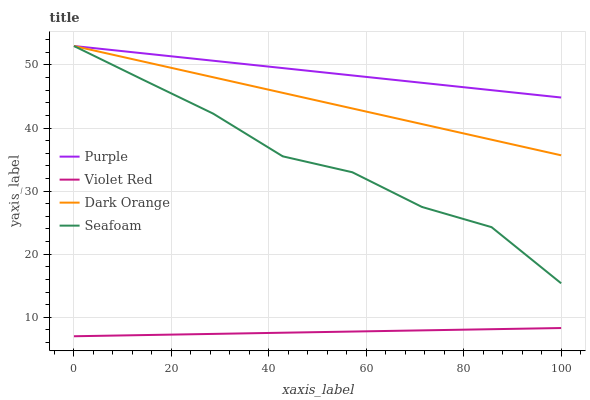Does Violet Red have the minimum area under the curve?
Answer yes or no. Yes. Does Purple have the maximum area under the curve?
Answer yes or no. Yes. Does Dark Orange have the minimum area under the curve?
Answer yes or no. No. Does Dark Orange have the maximum area under the curve?
Answer yes or no. No. Is Violet Red the smoothest?
Answer yes or no. Yes. Is Seafoam the roughest?
Answer yes or no. Yes. Is Dark Orange the smoothest?
Answer yes or no. No. Is Dark Orange the roughest?
Answer yes or no. No. Does Violet Red have the lowest value?
Answer yes or no. Yes. Does Dark Orange have the lowest value?
Answer yes or no. No. Does Seafoam have the highest value?
Answer yes or no. Yes. Does Violet Red have the highest value?
Answer yes or no. No. Is Violet Red less than Dark Orange?
Answer yes or no. Yes. Is Seafoam greater than Violet Red?
Answer yes or no. Yes. Does Seafoam intersect Purple?
Answer yes or no. Yes. Is Seafoam less than Purple?
Answer yes or no. No. Is Seafoam greater than Purple?
Answer yes or no. No. Does Violet Red intersect Dark Orange?
Answer yes or no. No. 